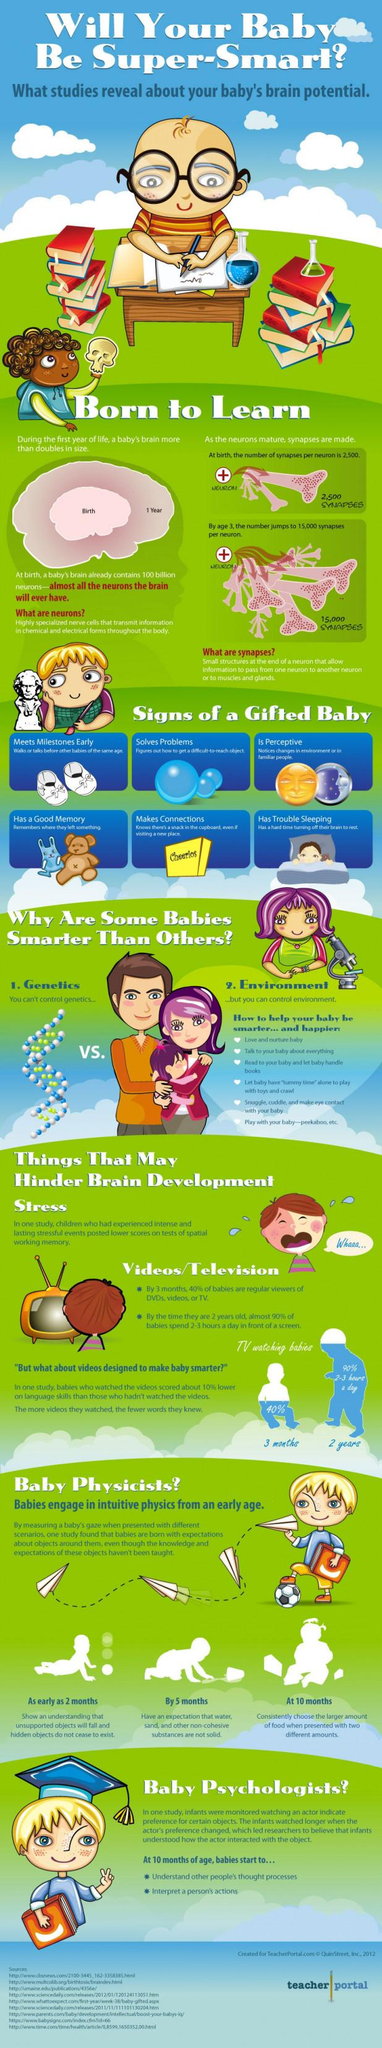Identify some key points in this picture. There are two points under the heading of videos/television. There are 6 points for a gifted baby. At 10 months of age, a baby is able to interpret a person's actions. 